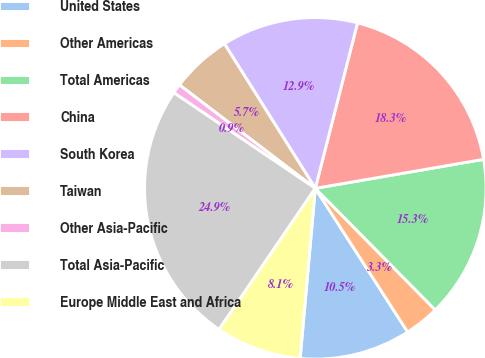Convert chart. <chart><loc_0><loc_0><loc_500><loc_500><pie_chart><fcel>United States<fcel>Other Americas<fcel>Total Americas<fcel>China<fcel>South Korea<fcel>Taiwan<fcel>Other Asia-Pacific<fcel>Total Asia-Pacific<fcel>Europe Middle East and Africa<nl><fcel>10.51%<fcel>3.3%<fcel>15.32%<fcel>18.31%<fcel>12.91%<fcel>5.71%<fcel>0.9%<fcel>24.93%<fcel>8.11%<nl></chart> 